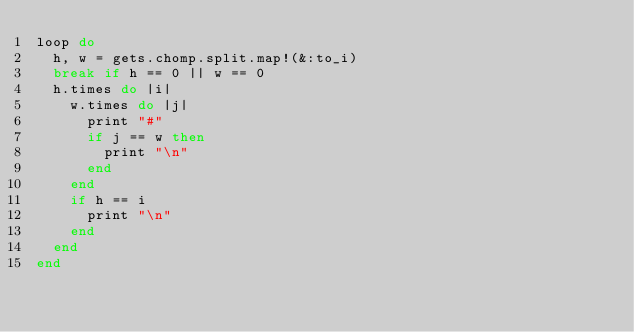Convert code to text. <code><loc_0><loc_0><loc_500><loc_500><_Ruby_>loop do
  h, w = gets.chomp.split.map!(&:to_i)
  break if h == 0 || w == 0
  h.times do |i|
    w.times do |j|
      print "#"
      if j == w then 
        print "\n"
      end
    end
    if h == i
      print "\n" 
    end
  end
end</code> 